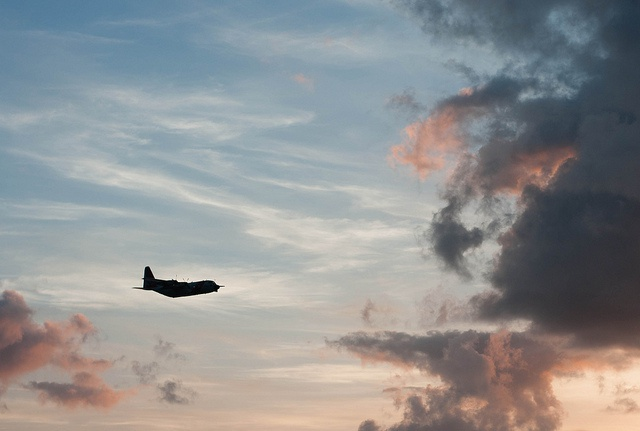Describe the objects in this image and their specific colors. I can see a airplane in gray, black, ivory, and darkgray tones in this image. 